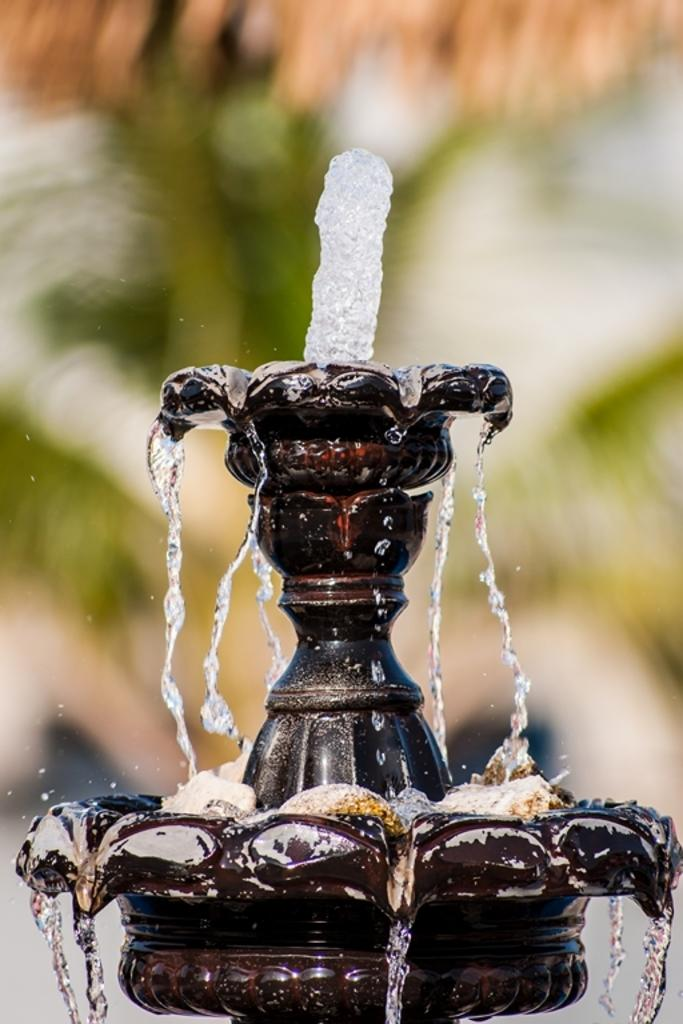What is the main subject in the image? There is a fountain in the image. Can you describe the background of the image? The background of the image is blurry. What type of headwear is worn by the volcano in the image? There is no volcano present in the image, and therefore no headwear can be observed. Is there any fire visible in the image? There is no fire visible in the image; the main subject is a fountain. 